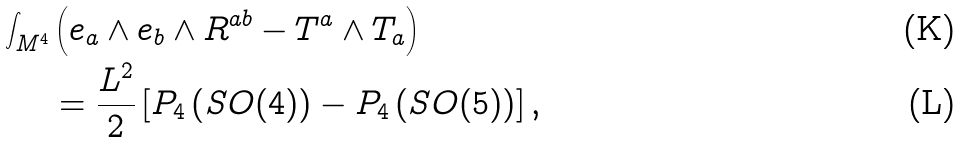<formula> <loc_0><loc_0><loc_500><loc_500>\int _ { M ^ { 4 } } & \left ( e _ { a } \wedge e _ { b } \wedge R ^ { a b } - T ^ { a } \wedge T _ { a } \right ) \\ & = \frac { L ^ { 2 } } { 2 } \left [ P _ { 4 } \left ( S O ( 4 ) \right ) - P _ { 4 } \left ( S O ( 5 ) \right ) \right ] ,</formula> 